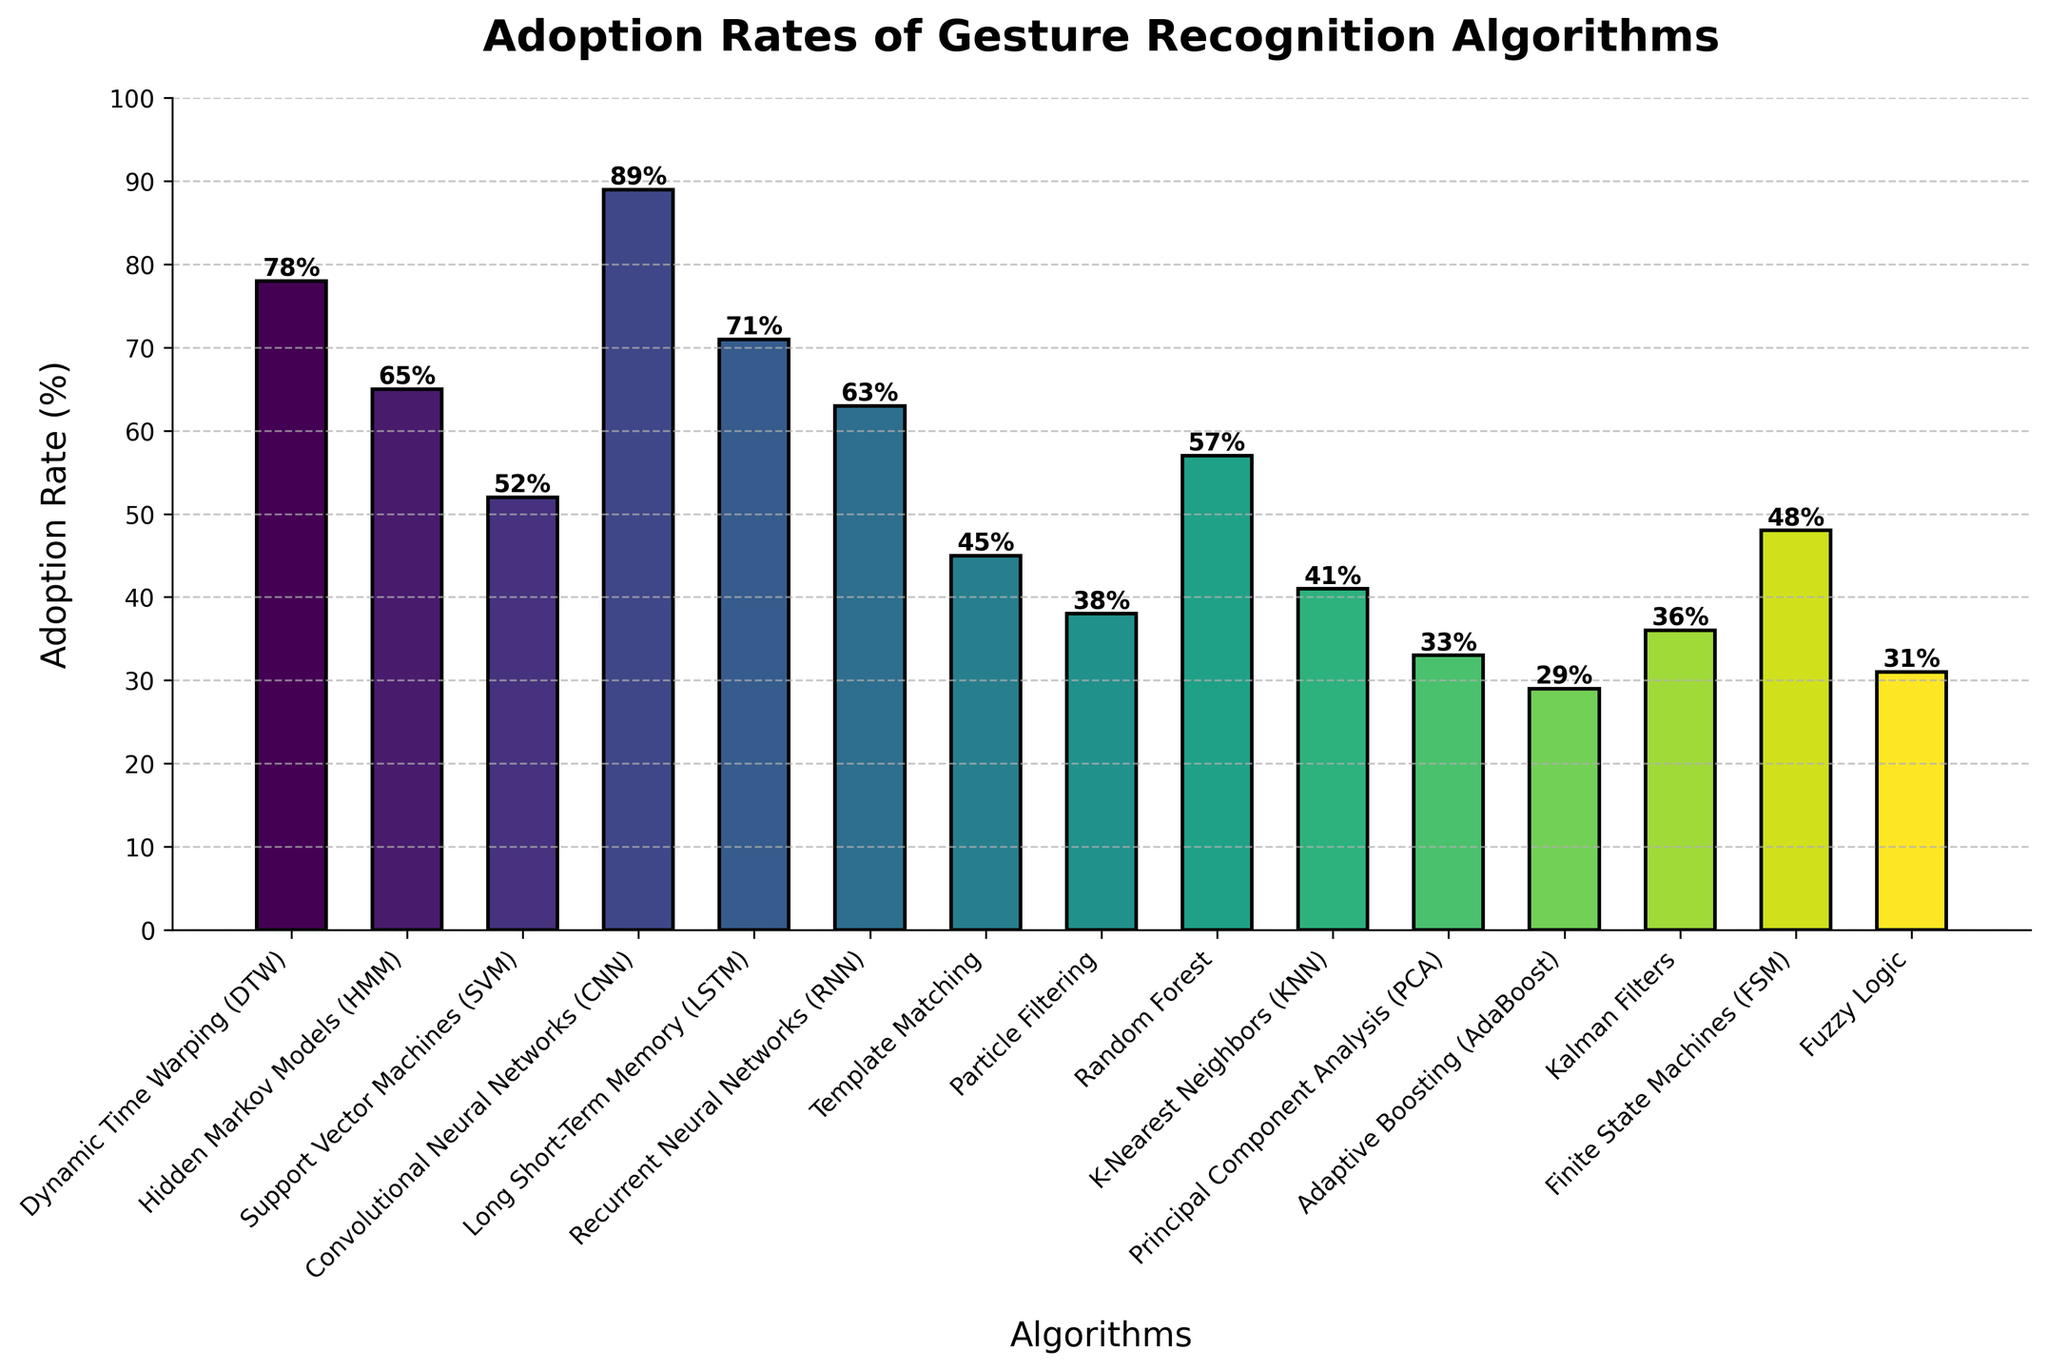What's the adoption rate of Convolutional Neural Networks (CNN)? Look at the bar height labeled "Convolutional Neural Networks (CNN)". It is marked as 89%.
Answer: 89% Which algorithm has the lowest adoption rate, and what is it? Identify the smallest bar in the chart, labeled "Adaptive Boosting (AdaBoost)" with an adoption rate of 29%.
Answer: Adaptive Boosting (AdaBoost), 29% What is the difference in adoption rates between Dynamic Time Warping (DTW) and Kalman Filters? Subtract the adoption rate of Kalman Filters (36%) from Dynamic Time Warping (DTW) (78%). 78% - 36% = 42%
Answer: 42% Are there more algorithms with an adoption rate above 50% or below 50%? Count the number of bars above and below the 50% mark. Above 50%: 7 algorithms. Below 50%: 8 algorithms.
Answer: Below 50% Which algorithm is adopted more: Support Vector Machines (SVM) or Recurrent Neural Networks (RNN)? Compare the heights of the bars labeled "Support Vector Machines (SVM)" (52%) and "Recurrent Neural Networks (RNN)" (63%). 63% > 52%
Answer: Recurrent Neural Networks (RNN) How many algorithms have an adoption rate between 30% and 40%, inclusive? Count the number of bars with heights between 30% and 40%. The bars for Fuzzy Logic (31%), Kalman Filters (36%), and Principal Component Analysis (33%).
Answer: 3 What is the sum of adoption rates for the top three most adopted algorithms? Identify the three highest adoption rates: Convolutional Neural Networks (89%), Dynamic Time Warping (78%), and Long Short-Term Memory (71%). Sum them: 89% + 78% + 71% = 238%
Answer: 238% Which algorithm has an adoption rate closer to 50% but not above it? Look at the bars around 50%, and the closest one below is Template Matching at 45%.
Answer: Template Matching Is the adoption rate of Hidden Markov Models (HMM) higher or lower than the average adoption rate of all algorithms? Calculate the average adoption rate: (Sum of all adoption rates) / 15. Total Sum = 727, Average = 727 / 15 ≈ 48.5%. Compare with HMM (65%). 65% > 48.5%
Answer: Higher 